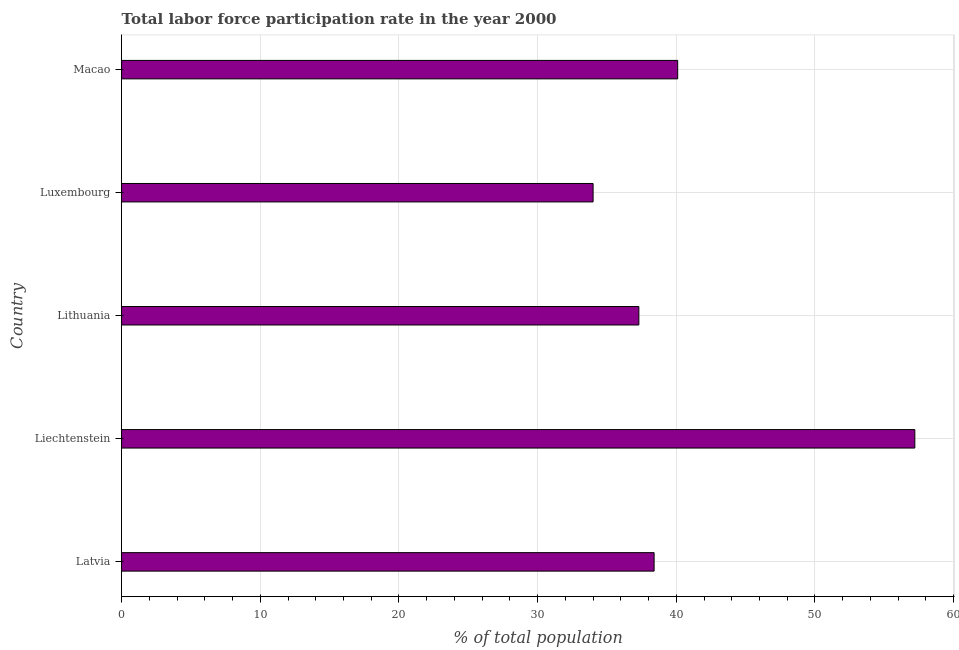Does the graph contain any zero values?
Provide a short and direct response. No. What is the title of the graph?
Ensure brevity in your answer.  Total labor force participation rate in the year 2000. What is the label or title of the X-axis?
Provide a succinct answer. % of total population. What is the label or title of the Y-axis?
Your answer should be very brief. Country. What is the total labor force participation rate in Macao?
Make the answer very short. 40.1. Across all countries, what is the maximum total labor force participation rate?
Offer a terse response. 57.2. In which country was the total labor force participation rate maximum?
Ensure brevity in your answer.  Liechtenstein. In which country was the total labor force participation rate minimum?
Offer a very short reply. Luxembourg. What is the sum of the total labor force participation rate?
Your response must be concise. 207. What is the difference between the total labor force participation rate in Latvia and Lithuania?
Provide a short and direct response. 1.1. What is the average total labor force participation rate per country?
Make the answer very short. 41.4. What is the median total labor force participation rate?
Your response must be concise. 38.4. In how many countries, is the total labor force participation rate greater than 22 %?
Give a very brief answer. 5. What is the ratio of the total labor force participation rate in Lithuania to that in Luxembourg?
Give a very brief answer. 1.1. Is the total labor force participation rate in Lithuania less than that in Macao?
Ensure brevity in your answer.  Yes. What is the difference between the highest and the second highest total labor force participation rate?
Make the answer very short. 17.1. Is the sum of the total labor force participation rate in Lithuania and Macao greater than the maximum total labor force participation rate across all countries?
Provide a short and direct response. Yes. What is the difference between the highest and the lowest total labor force participation rate?
Your answer should be compact. 23.2. In how many countries, is the total labor force participation rate greater than the average total labor force participation rate taken over all countries?
Ensure brevity in your answer.  1. How many bars are there?
Provide a succinct answer. 5. What is the difference between two consecutive major ticks on the X-axis?
Ensure brevity in your answer.  10. What is the % of total population in Latvia?
Ensure brevity in your answer.  38.4. What is the % of total population of Liechtenstein?
Keep it short and to the point. 57.2. What is the % of total population in Lithuania?
Ensure brevity in your answer.  37.3. What is the % of total population in Macao?
Give a very brief answer. 40.1. What is the difference between the % of total population in Latvia and Liechtenstein?
Your answer should be very brief. -18.8. What is the difference between the % of total population in Latvia and Lithuania?
Ensure brevity in your answer.  1.1. What is the difference between the % of total population in Latvia and Macao?
Keep it short and to the point. -1.7. What is the difference between the % of total population in Liechtenstein and Lithuania?
Make the answer very short. 19.9. What is the difference between the % of total population in Liechtenstein and Luxembourg?
Offer a terse response. 23.2. What is the difference between the % of total population in Liechtenstein and Macao?
Keep it short and to the point. 17.1. What is the ratio of the % of total population in Latvia to that in Liechtenstein?
Offer a terse response. 0.67. What is the ratio of the % of total population in Latvia to that in Luxembourg?
Make the answer very short. 1.13. What is the ratio of the % of total population in Latvia to that in Macao?
Your answer should be compact. 0.96. What is the ratio of the % of total population in Liechtenstein to that in Lithuania?
Your answer should be compact. 1.53. What is the ratio of the % of total population in Liechtenstein to that in Luxembourg?
Provide a succinct answer. 1.68. What is the ratio of the % of total population in Liechtenstein to that in Macao?
Provide a succinct answer. 1.43. What is the ratio of the % of total population in Lithuania to that in Luxembourg?
Your answer should be very brief. 1.1. What is the ratio of the % of total population in Lithuania to that in Macao?
Your answer should be compact. 0.93. What is the ratio of the % of total population in Luxembourg to that in Macao?
Your answer should be very brief. 0.85. 